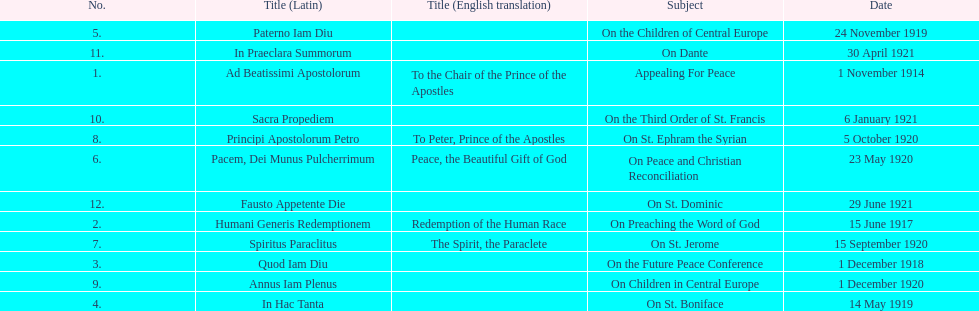What are all the subjects? Appealing For Peace, On Preaching the Word of God, On the Future Peace Conference, On St. Boniface, On the Children of Central Europe, On Peace and Christian Reconciliation, On St. Jerome, On St. Ephram the Syrian, On Children in Central Europe, On the Third Order of St. Francis, On Dante, On St. Dominic. What are their dates? 1 November 1914, 15 June 1917, 1 December 1918, 14 May 1919, 24 November 1919, 23 May 1920, 15 September 1920, 5 October 1920, 1 December 1920, 6 January 1921, 30 April 1921, 29 June 1921. Which subject's date belongs to 23 may 1920? On Peace and Christian Reconciliation. 